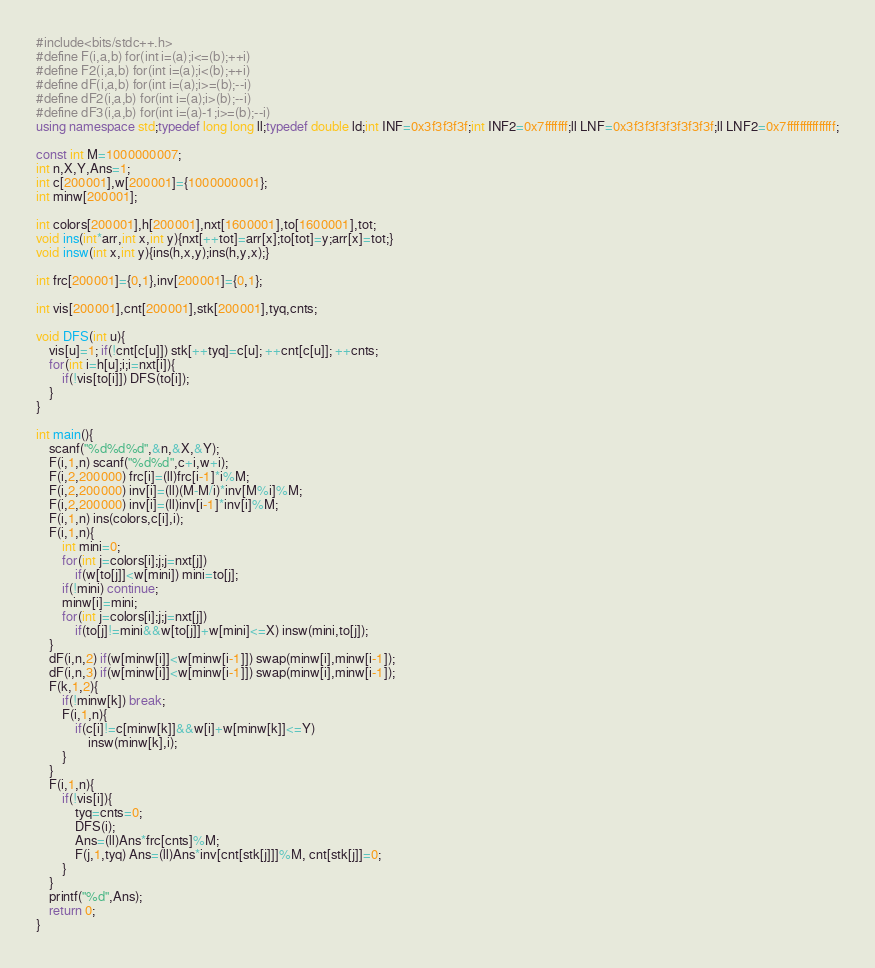Convert code to text. <code><loc_0><loc_0><loc_500><loc_500><_C++_>#include<bits/stdc++.h>
#define F(i,a,b) for(int i=(a);i<=(b);++i)
#define F2(i,a,b) for(int i=(a);i<(b);++i)
#define dF(i,a,b) for(int i=(a);i>=(b);--i)
#define dF2(i,a,b) for(int i=(a);i>(b);--i)
#define dF3(i,a,b) for(int i=(a)-1;i>=(b);--i)
using namespace std;typedef long long ll;typedef double ld;int INF=0x3f3f3f3f;int INF2=0x7fffffff;ll LNF=0x3f3f3f3f3f3f3f3f;ll LNF2=0x7fffffffffffffff;

const int M=1000000007;
int n,X,Y,Ans=1;
int c[200001],w[200001]={1000000001};
int minw[200001];

int colors[200001],h[200001],nxt[1600001],to[1600001],tot;
void ins(int*arr,int x,int y){nxt[++tot]=arr[x];to[tot]=y;arr[x]=tot;}
void insw(int x,int y){ins(h,x,y);ins(h,y,x);}

int frc[200001]={0,1},inv[200001]={0,1};

int vis[200001],cnt[200001],stk[200001],tyq,cnts;

void DFS(int u){
	vis[u]=1; if(!cnt[c[u]]) stk[++tyq]=c[u]; ++cnt[c[u]]; ++cnts;
	for(int i=h[u];i;i=nxt[i]){
		if(!vis[to[i]]) DFS(to[i]);
	}
}

int main(){
	scanf("%d%d%d",&n,&X,&Y);
	F(i,1,n) scanf("%d%d",c+i,w+i);
	F(i,2,200000) frc[i]=(ll)frc[i-1]*i%M;
	F(i,2,200000) inv[i]=(ll)(M-M/i)*inv[M%i]%M;
	F(i,2,200000) inv[i]=(ll)inv[i-1]*inv[i]%M;
	F(i,1,n) ins(colors,c[i],i);
	F(i,1,n){
		int mini=0;
		for(int j=colors[i];j;j=nxt[j])
			if(w[to[j]]<w[mini]) mini=to[j];
		if(!mini) continue;
		minw[i]=mini;
		for(int j=colors[i];j;j=nxt[j])
			if(to[j]!=mini&&w[to[j]]+w[mini]<=X) insw(mini,to[j]);
	}
	dF(i,n,2) if(w[minw[i]]<w[minw[i-1]]) swap(minw[i],minw[i-1]);
	dF(i,n,3) if(w[minw[i]]<w[minw[i-1]]) swap(minw[i],minw[i-1]);
	F(k,1,2){
		if(!minw[k]) break;
		F(i,1,n){
			if(c[i]!=c[minw[k]]&&w[i]+w[minw[k]]<=Y)
				insw(minw[k],i);
		}
	}
	F(i,1,n){
		if(!vis[i]){
			tyq=cnts=0;
			DFS(i);
			Ans=(ll)Ans*frc[cnts]%M;
			F(j,1,tyq) Ans=(ll)Ans*inv[cnt[stk[j]]]%M, cnt[stk[j]]=0;
		}
	}
	printf("%d",Ans);
	return 0;
}</code> 